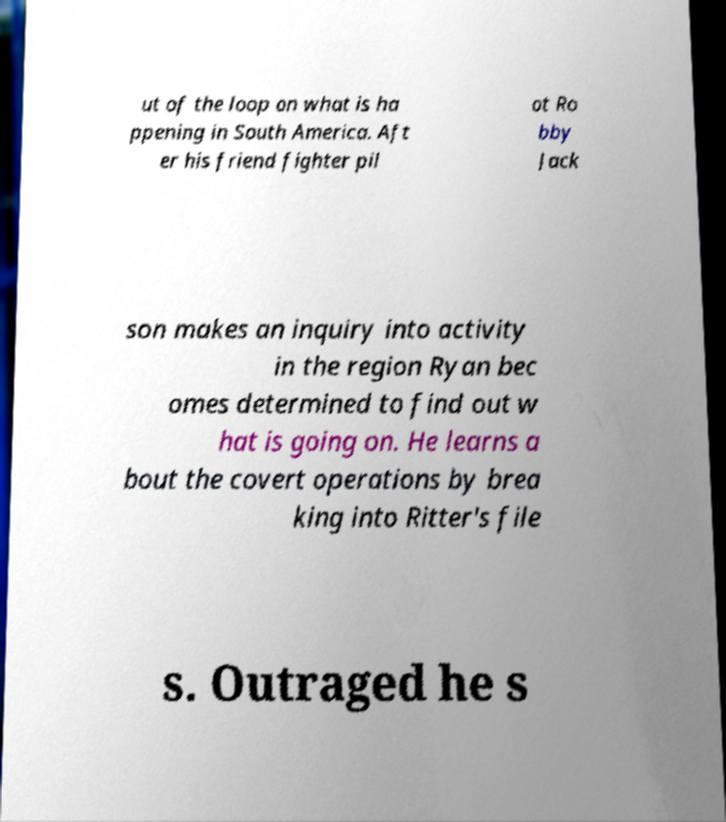Please identify and transcribe the text found in this image. ut of the loop on what is ha ppening in South America. Aft er his friend fighter pil ot Ro bby Jack son makes an inquiry into activity in the region Ryan bec omes determined to find out w hat is going on. He learns a bout the covert operations by brea king into Ritter's file s. Outraged he s 